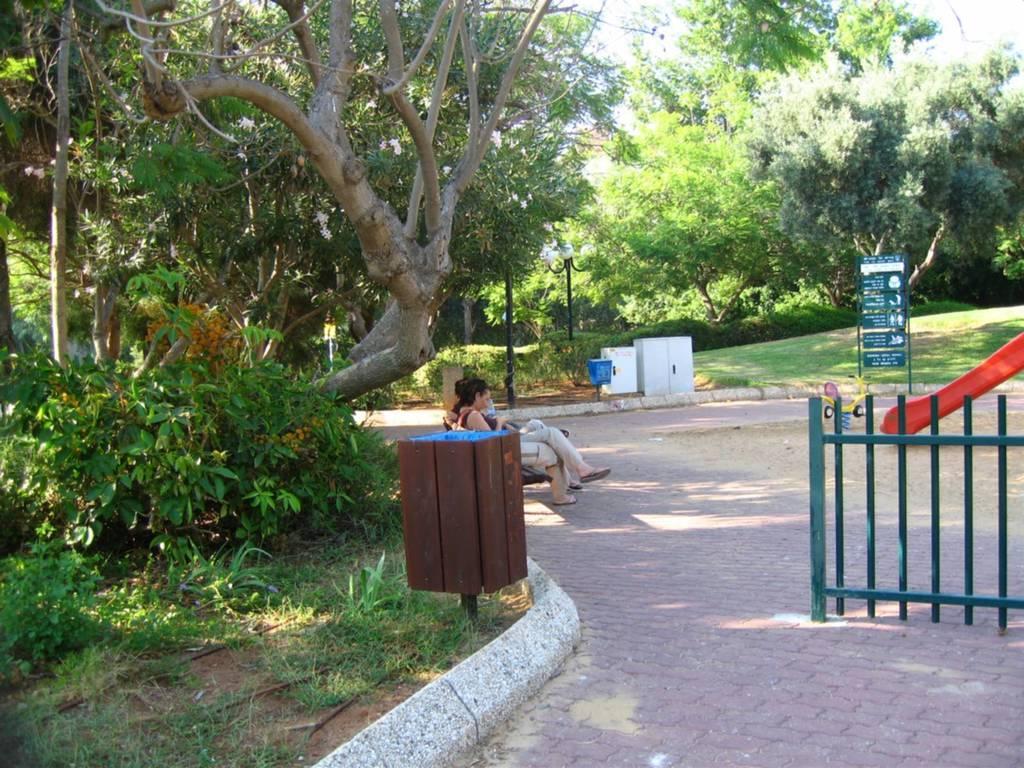Describe this image in one or two sentences. There is an instruction board on the right side. There is a wooden fence on the right side. This is a tree. There are two people sitting on wooden chair at the center. There is a street lamp at the center. 